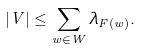<formula> <loc_0><loc_0><loc_500><loc_500>| V | \leq \sum _ { w \in W } \lambda _ { F ( w ) } .</formula> 